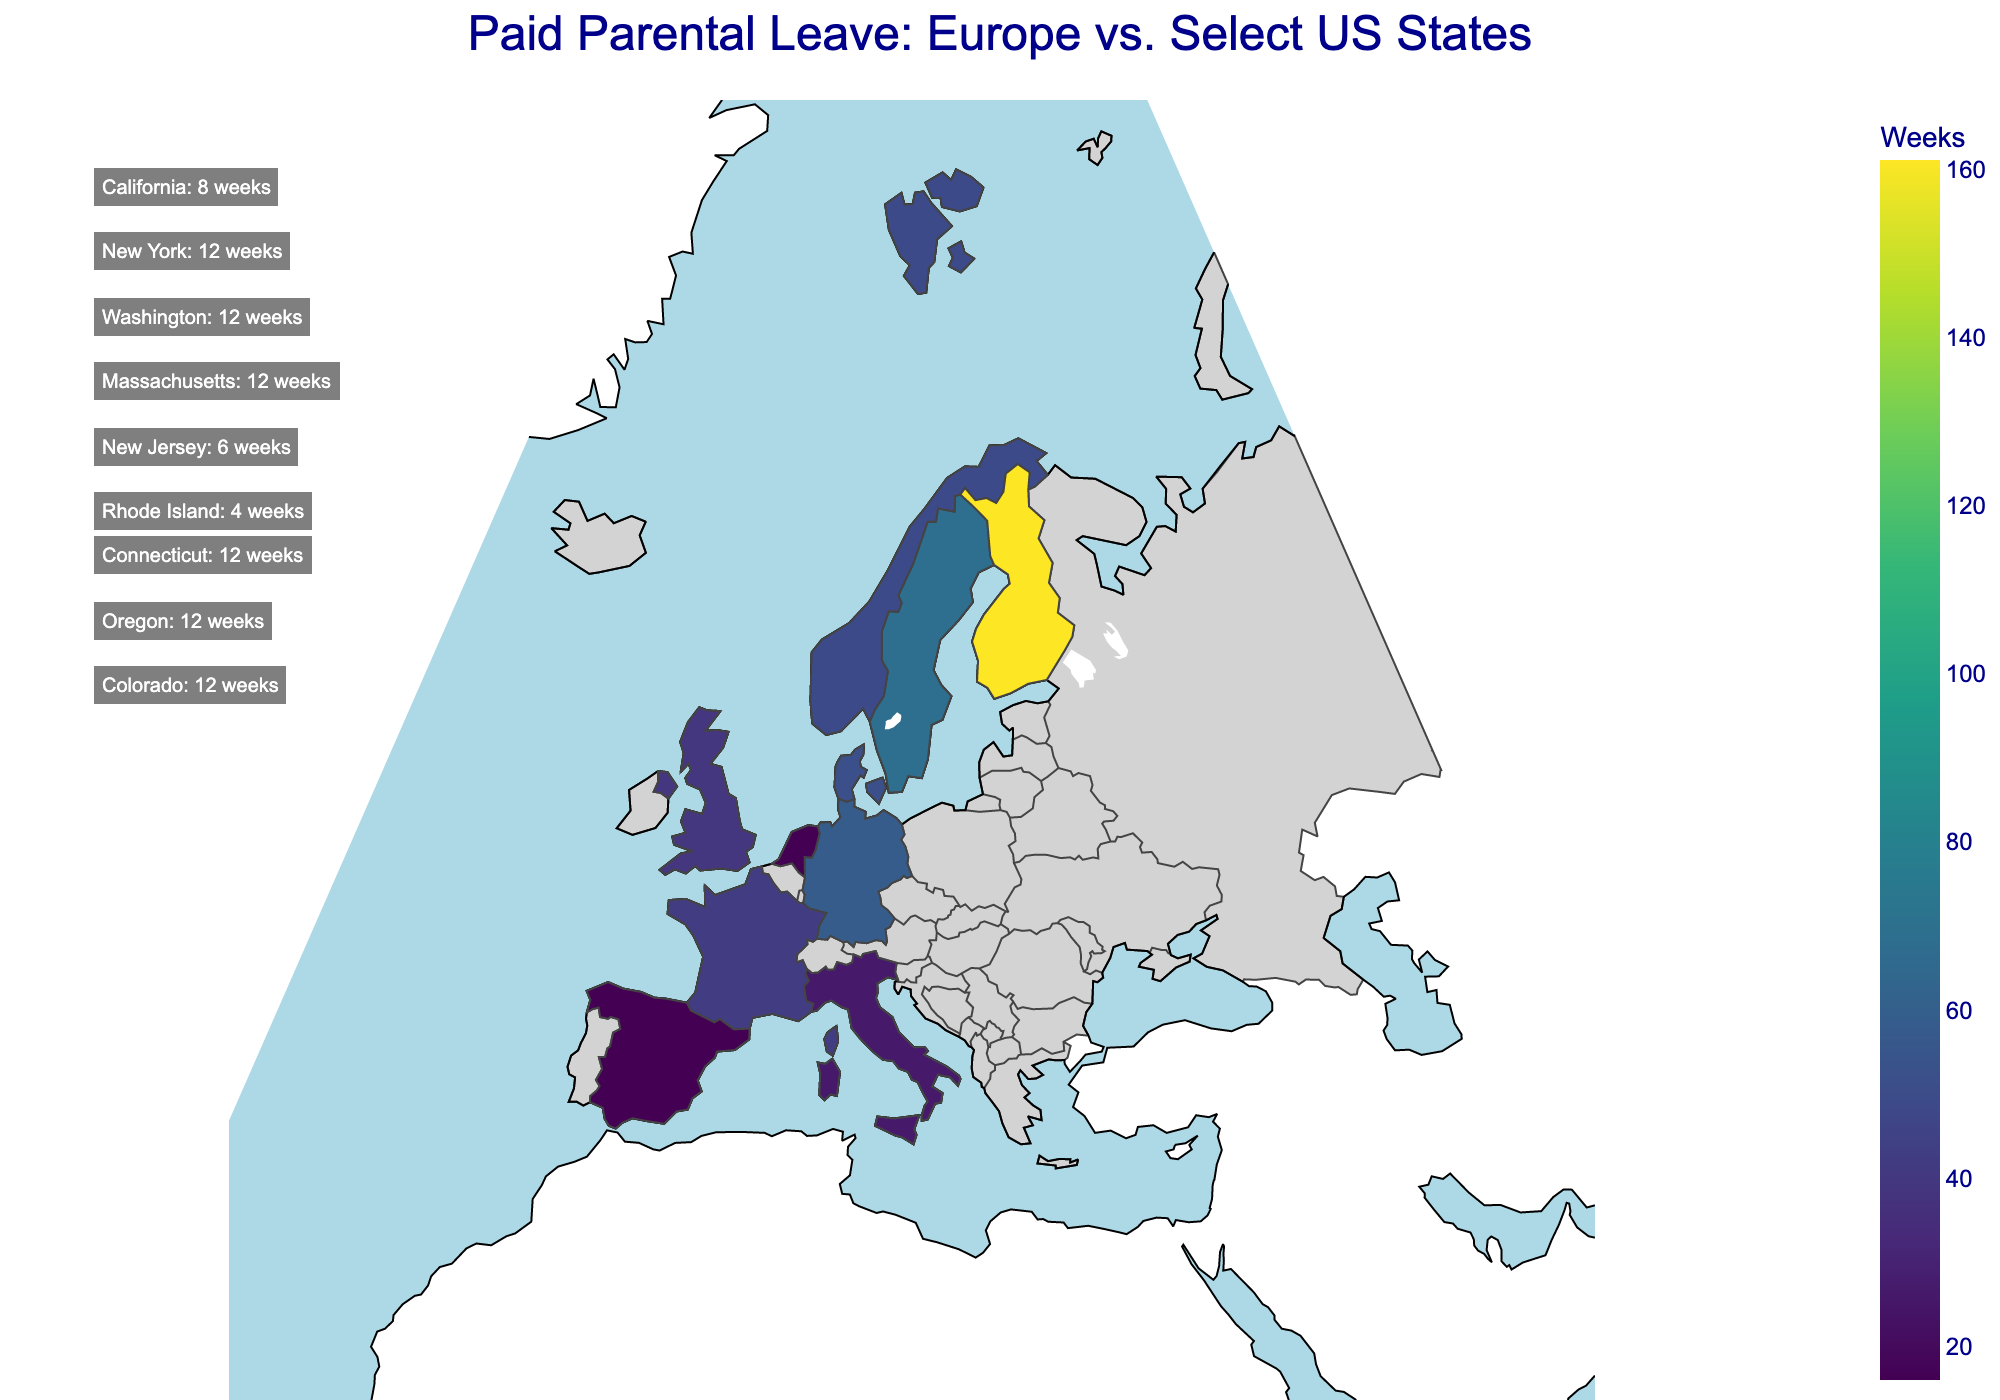What is the title of the plot? The title is prominently displayed at the top of the plot. It summarizes the data being presented and generally provides context about the figure.
Answer: Paid Parental Leave: Europe vs. Select US States How many US states are shown in the text annotations? Annotations are text boxes mentioning specific details. In this figure, you can count the number of such text boxes to find the number of US states.
Answer: 9 Which European country offers the most weeks of paid parental leave? Looking at the color gradient on the map and the hover information, identify the country with the darkest color indicating the highest value.
Answer: Finland How does the paid parental leave in New York compare to the United Kingdom? Find the values for New York from the annotations (12 weeks) and the United Kingdom by hovering on the map (39 weeks), then compare these values.
Answer: New York: 12 weeks, United Kingdom: 39 weeks Which US state has the smallest amount of paid parental leave, and how many weeks is it? Refer to the text annotations listing US states' parental leave weeks and look for the smallest number.
Answer: Rhode Island, 4 weeks Calculate the average paid parental leave for the US states shown. Add up the weeks for all US states (8 + 12 + 12 + 12 + 6 + 4 + 12 + 12 + 12), then divide by the number of states (9).
Answer: Average: 10 weeks What is the range of paid parental leave in the European countries shown? Identify the maximum and minimum values from the European countries on the map and find the difference. Max is Finland (161 weeks), Min is Spain/Netherlands (16 weeks). Subtract the smallest value from the largest.
Answer: Range: 145 weeks How does Germany's paid parental leave compare to France's? Find Germany's value by hovering over Germany on the map (58 weeks) and France's value by hovering over France (42 weeks), then compare.
Answer: Germany: 58 weeks, France: 42 weeks List three European countries with more than 50 weeks of paid parental leave. By hovering over countries on the map, identify those with values exceeding 50 weeks.
Answer: Finland, Germany, Denmark 